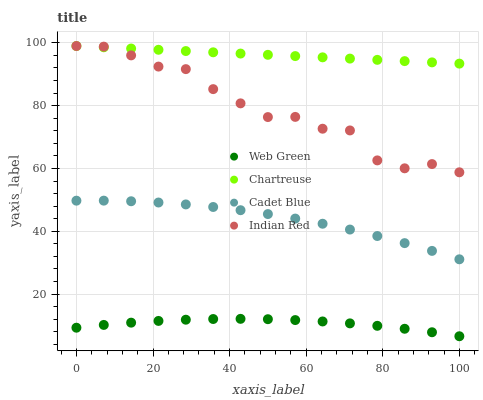Does Web Green have the minimum area under the curve?
Answer yes or no. Yes. Does Chartreuse have the maximum area under the curve?
Answer yes or no. Yes. Does Cadet Blue have the minimum area under the curve?
Answer yes or no. No. Does Cadet Blue have the maximum area under the curve?
Answer yes or no. No. Is Chartreuse the smoothest?
Answer yes or no. Yes. Is Indian Red the roughest?
Answer yes or no. Yes. Is Cadet Blue the smoothest?
Answer yes or no. No. Is Cadet Blue the roughest?
Answer yes or no. No. Does Web Green have the lowest value?
Answer yes or no. Yes. Does Cadet Blue have the lowest value?
Answer yes or no. No. Does Indian Red have the highest value?
Answer yes or no. Yes. Does Cadet Blue have the highest value?
Answer yes or no. No. Is Web Green less than Chartreuse?
Answer yes or no. Yes. Is Indian Red greater than Cadet Blue?
Answer yes or no. Yes. Does Chartreuse intersect Indian Red?
Answer yes or no. Yes. Is Chartreuse less than Indian Red?
Answer yes or no. No. Is Chartreuse greater than Indian Red?
Answer yes or no. No. Does Web Green intersect Chartreuse?
Answer yes or no. No. 